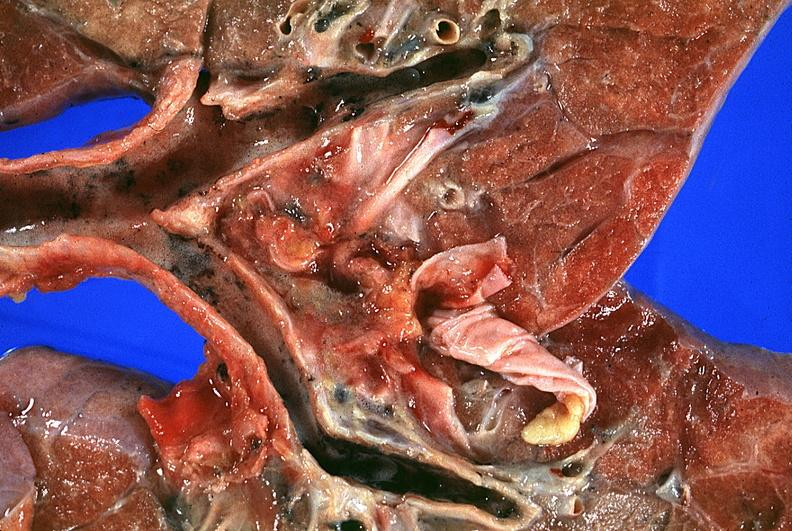s respiratory present?
Answer the question using a single word or phrase. Yes 